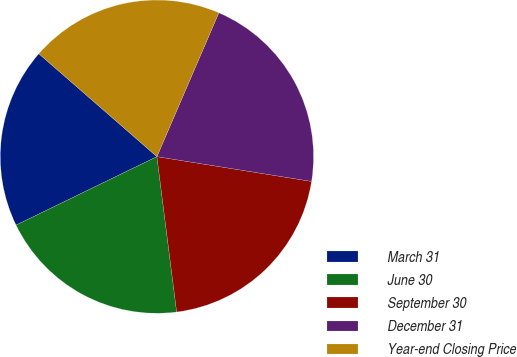<chart> <loc_0><loc_0><loc_500><loc_500><pie_chart><fcel>March 31<fcel>June 30<fcel>September 30<fcel>December 31<fcel>Year-end Closing Price<nl><fcel>18.61%<fcel>19.81%<fcel>20.46%<fcel>21.06%<fcel>20.06%<nl></chart> 